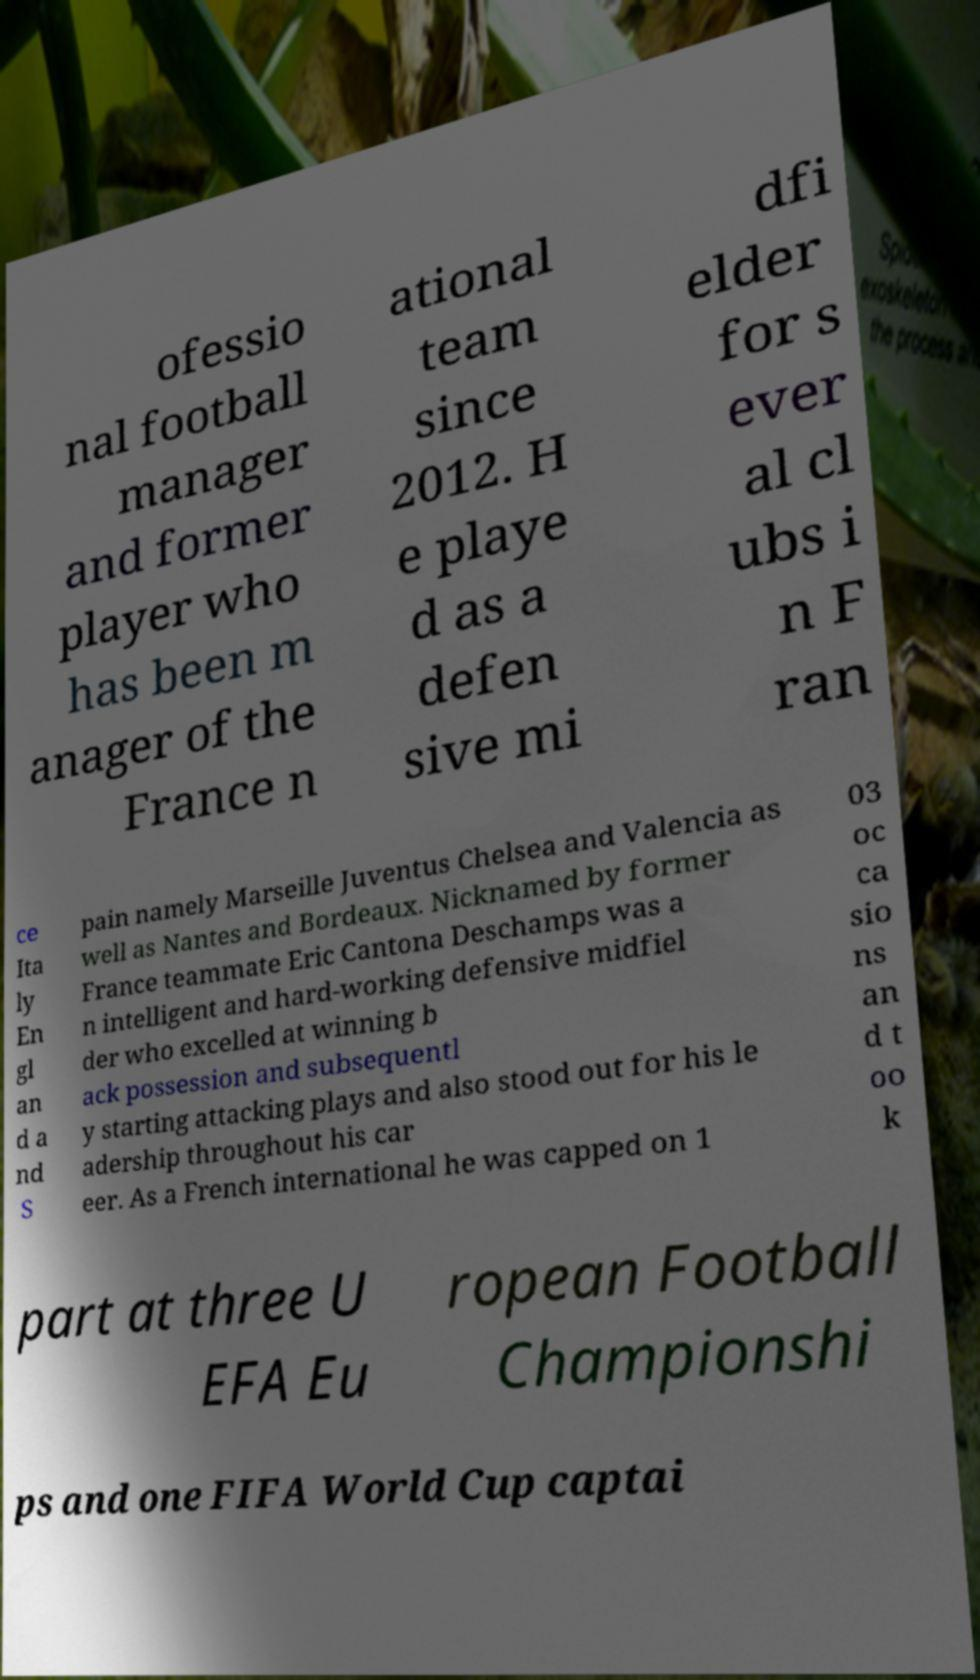Can you read and provide the text displayed in the image?This photo seems to have some interesting text. Can you extract and type it out for me? ofessio nal football manager and former player who has been m anager of the France n ational team since 2012. H e playe d as a defen sive mi dfi elder for s ever al cl ubs i n F ran ce Ita ly En gl an d a nd S pain namely Marseille Juventus Chelsea and Valencia as well as Nantes and Bordeaux. Nicknamed by former France teammate Eric Cantona Deschamps was a n intelligent and hard-working defensive midfiel der who excelled at winning b ack possession and subsequentl y starting attacking plays and also stood out for his le adership throughout his car eer. As a French international he was capped on 1 03 oc ca sio ns an d t oo k part at three U EFA Eu ropean Football Championshi ps and one FIFA World Cup captai 